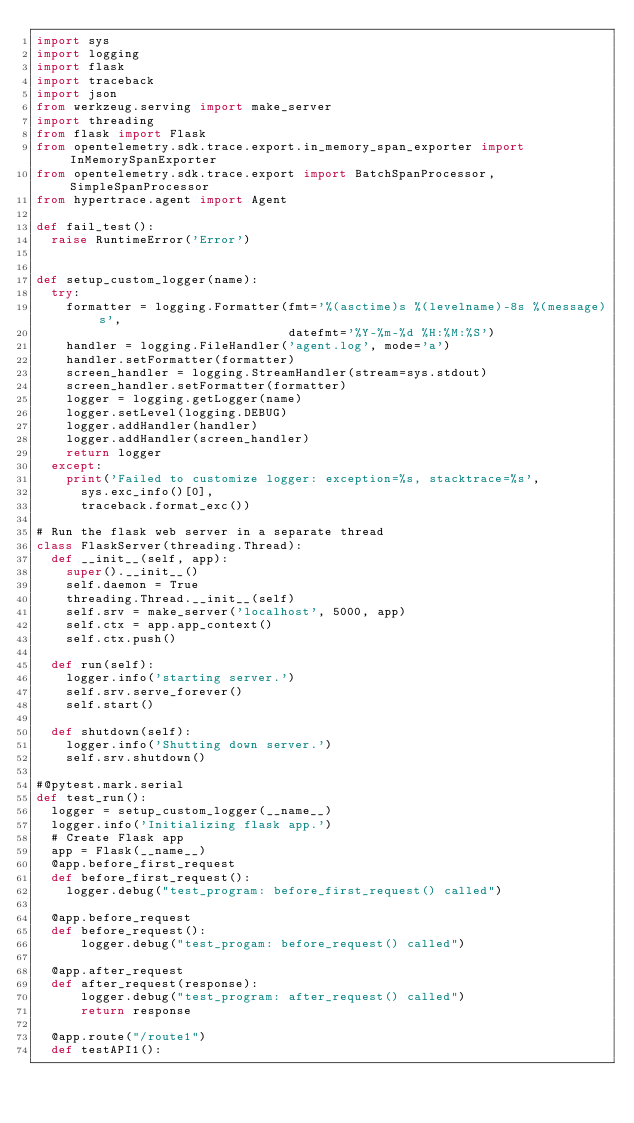<code> <loc_0><loc_0><loc_500><loc_500><_Python_>import sys
import logging
import flask
import traceback
import json
from werkzeug.serving import make_server
import threading
from flask import Flask
from opentelemetry.sdk.trace.export.in_memory_span_exporter import InMemorySpanExporter
from opentelemetry.sdk.trace.export import BatchSpanProcessor, SimpleSpanProcessor
from hypertrace.agent import Agent

def fail_test():
  raise RuntimeError('Error')


def setup_custom_logger(name):
  try:
    formatter = logging.Formatter(fmt='%(asctime)s %(levelname)-8s %(message)s',
                                  datefmt='%Y-%m-%d %H:%M:%S')
    handler = logging.FileHandler('agent.log', mode='a')
    handler.setFormatter(formatter)
    screen_handler = logging.StreamHandler(stream=sys.stdout)
    screen_handler.setFormatter(formatter)
    logger = logging.getLogger(name)
    logger.setLevel(logging.DEBUG)
    logger.addHandler(handler)
    logger.addHandler(screen_handler)
    return logger
  except:
    print('Failed to customize logger: exception=%s, stacktrace=%s',
      sys.exc_info()[0],
      traceback.format_exc())

# Run the flask web server in a separate thread
class FlaskServer(threading.Thread):
  def __init__(self, app):
    super().__init__()
    self.daemon = True
    threading.Thread.__init__(self)
    self.srv = make_server('localhost', 5000, app)
    self.ctx = app.app_context()
    self.ctx.push()

  def run(self):
    logger.info('starting server.')
    self.srv.serve_forever()
    self.start()

  def shutdown(self):
    logger.info('Shutting down server.')
    self.srv.shutdown()

#@pytest.mark.serial
def test_run():
  logger = setup_custom_logger(__name__)
  logger.info('Initializing flask app.')
  # Create Flask app
  app = Flask(__name__)
  @app.before_first_request
  def before_first_request():
    logger.debug("test_program: before_first_request() called")

  @app.before_request
  def before_request():
      logger.debug("test_progam: before_request() called")

  @app.after_request
  def after_request(response):
      logger.debug("test_program: after_request() called")
      return response

  @app.route("/route1")
  def testAPI1():</code> 